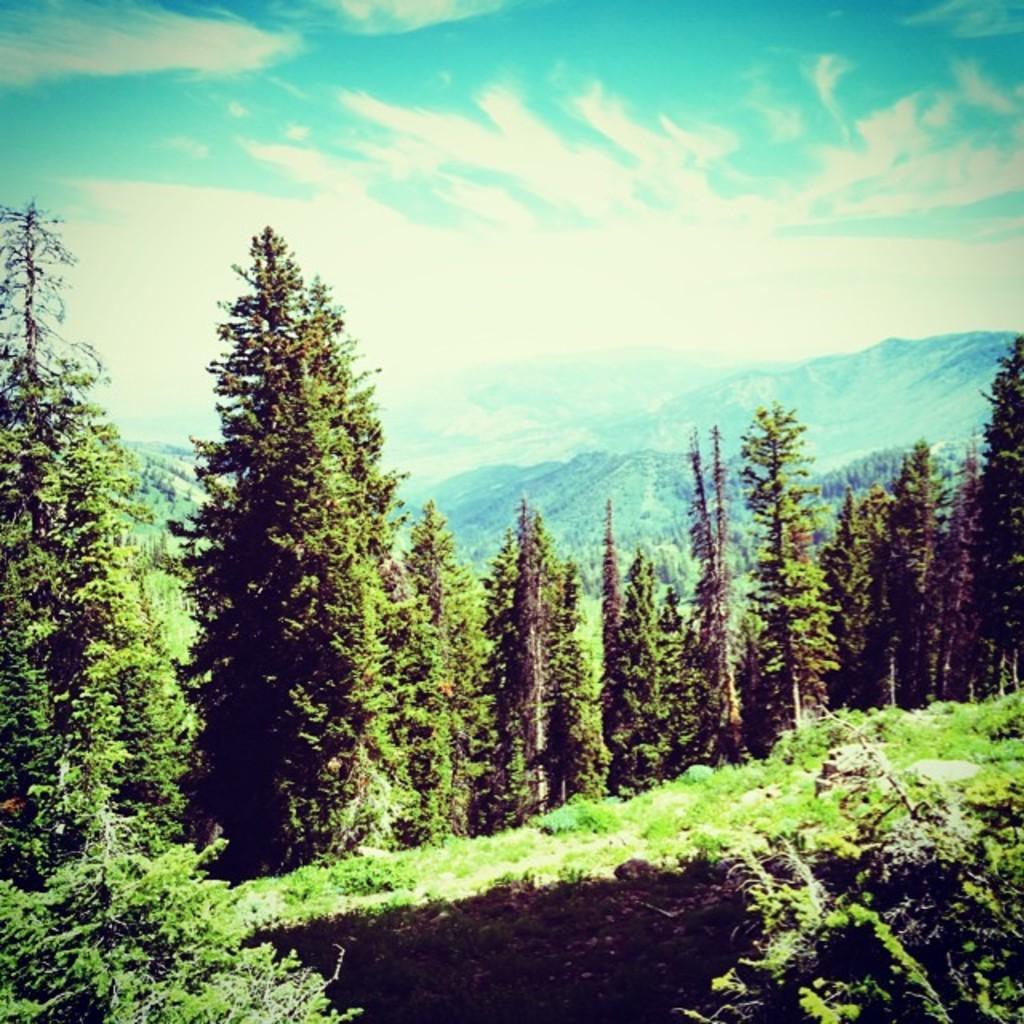Describe this image in one or two sentences. In the image in the center we can see the sky,clouds,trees,plants,hills and grass. 